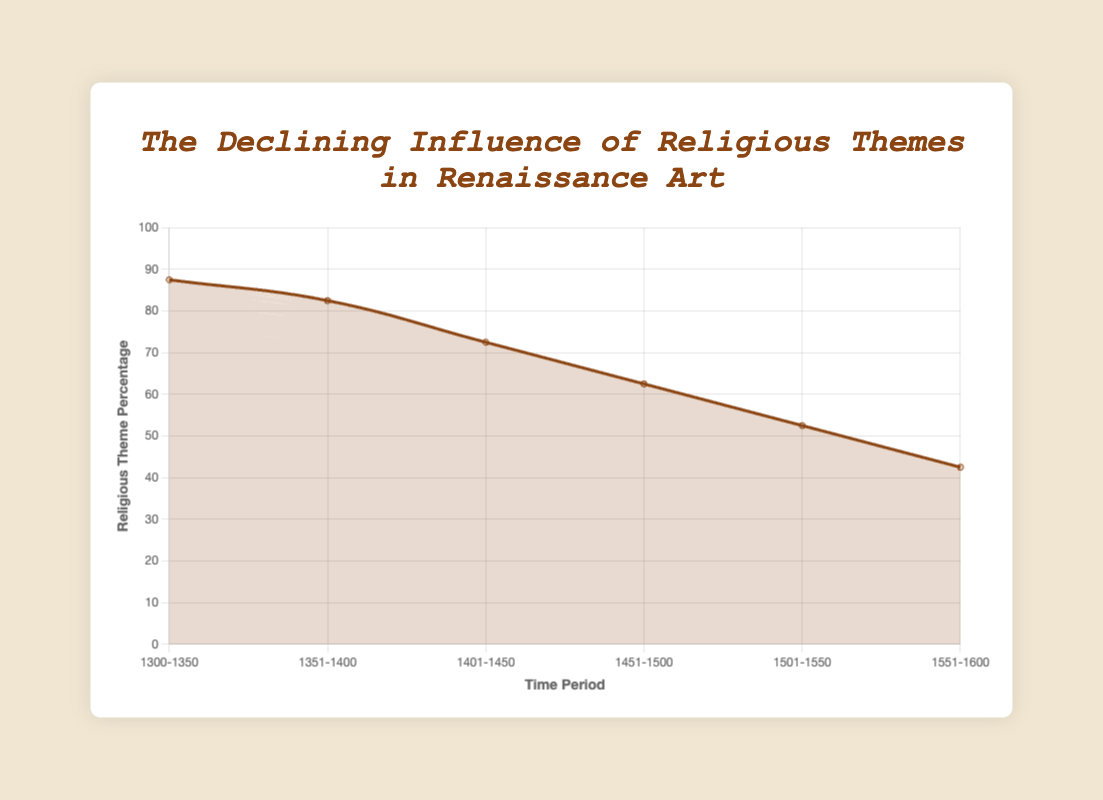What is the overall trend of religious theme percentage from 1300 to 1600? The graph shows a general decline in the percentage of religious themes in art from 87.5% in the 1300-1350 period to 42.5% in the 1551-1600 period. We observe a consistent downward slope across the time periods.
Answer: A general decline How much did the religious theme percentage decline from 1300-1350 to 1551-1600? To calculate the overall decline, subtract the percentage in the 1551-1600 period (42.5%) from the percentage in the 1300-1350 period (87.5%). The decline is 87.5% - 42.5% = 45%.
Answer: 45% In which time period did the religious theme percentage show the most significant drop? By examining the downward intervals between each time period in the graph, we can see the largest drop occurred between 1401-1450 (72.5%) and 1451-1500 (62.5%), which is a 10% decline.
Answer: 1401-1450 to 1451-1500 What is the average religious theme percentage over the entire period from 1300 to 1600? Sum the religious theme percentages for all time periods: 87.5 + 82.5 + 72.5 + 62.5 + 52.5 + 42.5 = 400. Then divide by the number of periods (6). The average is 400 / 6 = 66.67%.
Answer: 66.67% Is the religious theme percentage in 1501-1550 higher or lower than in 1451-1500? From the graph, the percentage in 1451-1500 is 62.5% and in 1501-1550 it is 52.5%. Therefore, it is lower in 1501-1550.
Answer: Lower How many time periods have a religious theme percentage above 70%? By looking at the graph, the periods with percentages above 70% are 1300-1350 (87.5%), 1351-1400 (82.5%), and 1401-1450 (72.5%). There are 3 periods in total.
Answer: 3 What is the difference in religious theme percentage between the beginning period (1300-1350) and the midpoint period (1451-1500)? The percentage in the beginning period (1300-1350) is 87.5%, and in the midpoint period (1451-1500) it is 62.5%. The difference is 87.5% - 62.5% = 25%.
Answer: 25% Visually, which time period shows a significant decrease in the curve's slope? The slope between 1401-1450 and 1451-1500 appears steeper than other sections, indicating a larger decrease during this period.
Answer: 1401-1450 to 1451-1500 From the visual representation, which time period has the flattest slope, indicating the least change in religious theme percentage? The time period from 1351-1400 to 1401-1450 has the flattest slope, indicating the smallest decrease (82.5% to 72.5%, a 10% drop).
Answer: 1351-1400 to 1401-1450 